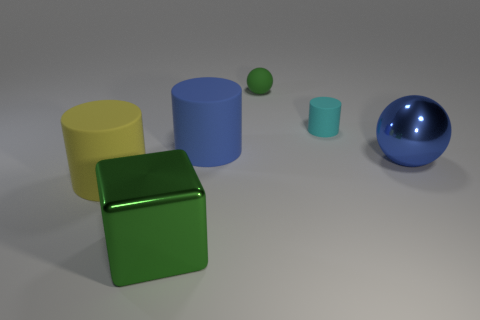There is a large object that is the same shape as the tiny green object; what color is it?
Keep it short and to the point. Blue. How many big green objects are the same material as the big cube?
Ensure brevity in your answer.  0. How many metallic spheres are in front of the big metallic object on the left side of the blue shiny thing?
Ensure brevity in your answer.  0. Are there any green objects to the right of the green matte sphere?
Give a very brief answer. No. There is a big blue thing on the right side of the small cyan rubber thing; does it have the same shape as the blue matte thing?
Offer a terse response. No. What material is the big thing that is the same color as the tiny ball?
Provide a succinct answer. Metal. How many small matte spheres are the same color as the block?
Offer a very short reply. 1. The large metallic thing on the left side of the large blue object to the right of the big blue matte cylinder is what shape?
Make the answer very short. Cube. Is there another large rubber object that has the same shape as the large yellow object?
Provide a succinct answer. Yes. Do the big sphere and the big metal thing to the left of the blue metal ball have the same color?
Give a very brief answer. No. 